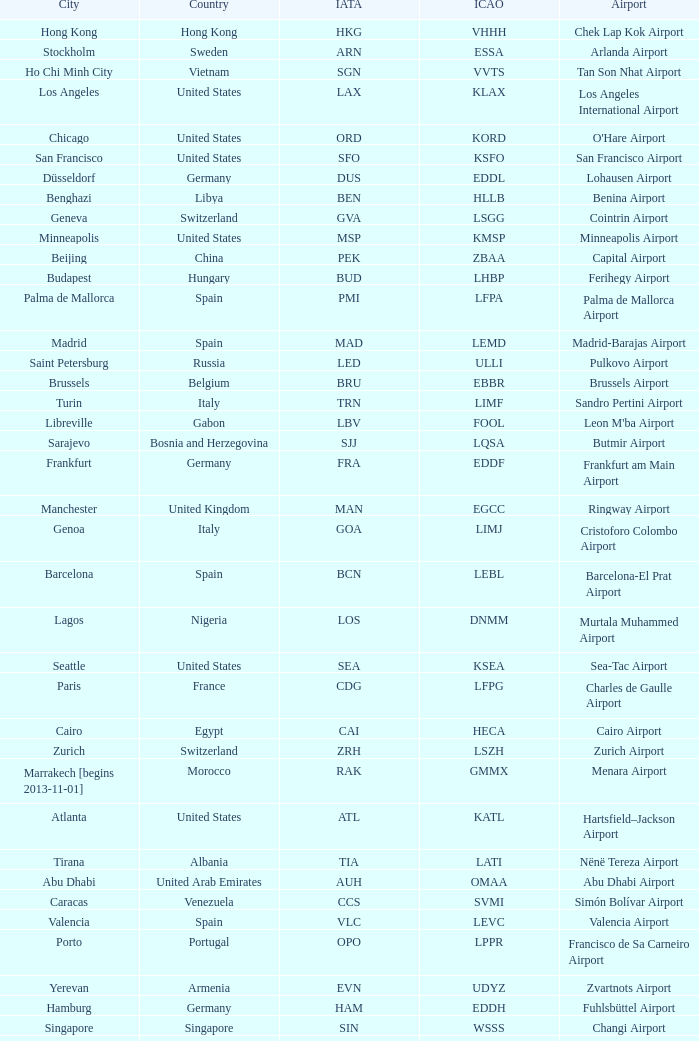What city is fuhlsbüttel airport in? Hamburg. 